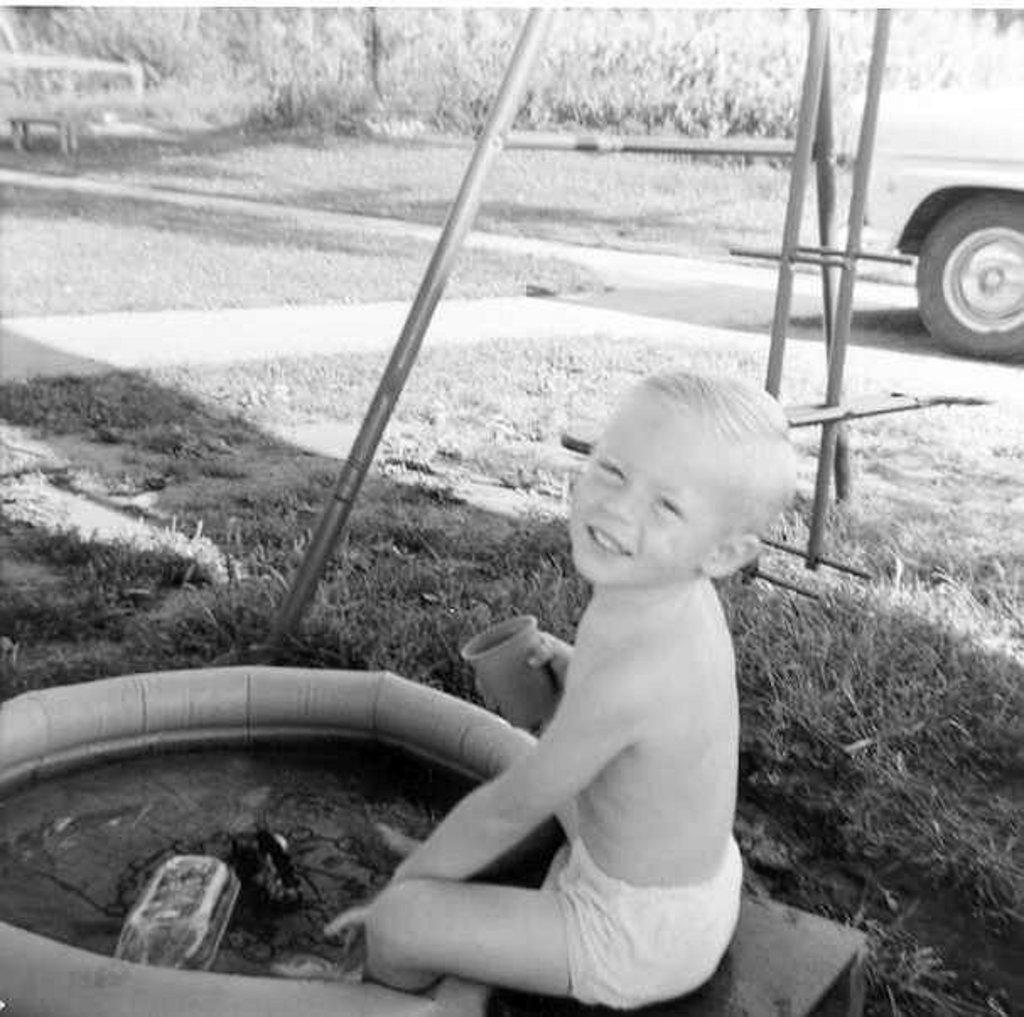What is the color scheme of the image? The image is black and white. What is the boy doing in the image? The boy is sitting in the garden. What object is in front of the boy? The boy has a tube in front of him. What objects are behind the boy? There is an iron rod and a truck behind the boy. What can be seen in the background of the image? There are plants in the background. What type of disease is the boy suffering from in the image? There is no indication in the image that the boy is suffering from any disease. What kind of space-related objects can be seen in the image? There are no space-related objects present in the image. 